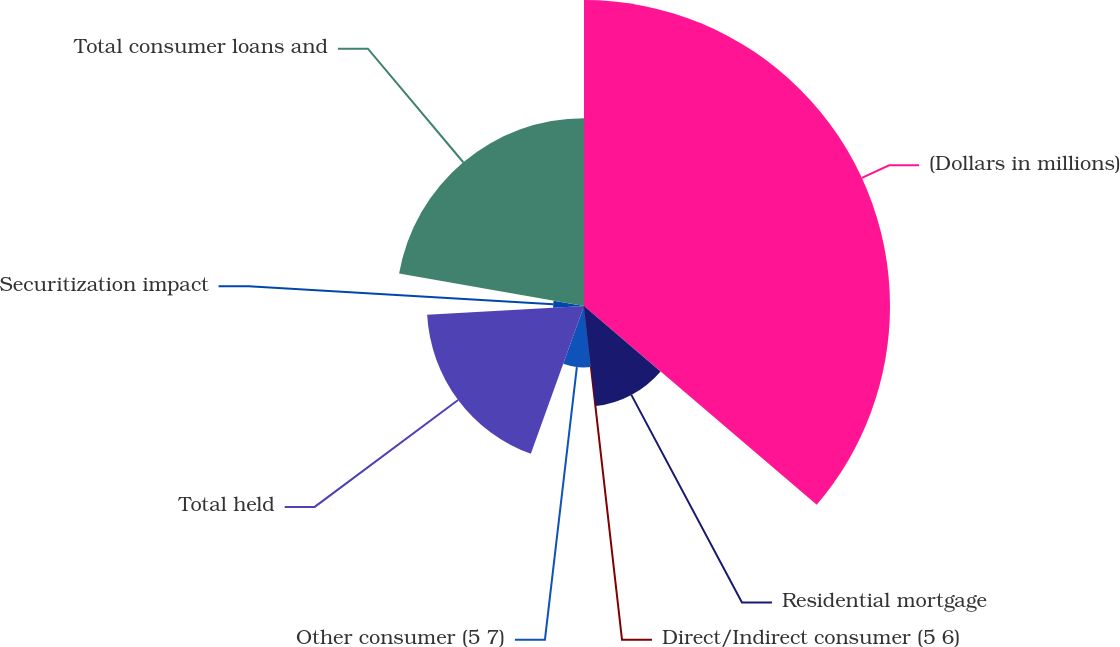Convert chart. <chart><loc_0><loc_0><loc_500><loc_500><pie_chart><fcel>(Dollars in millions)<fcel>Residential mortgage<fcel>Direct/Indirect consumer (5 6)<fcel>Other consumer (5 7)<fcel>Total held<fcel>Securitization impact<fcel>Total consumer loans and<nl><fcel>36.25%<fcel>11.93%<fcel>0.04%<fcel>7.28%<fcel>18.61%<fcel>3.66%<fcel>22.24%<nl></chart> 